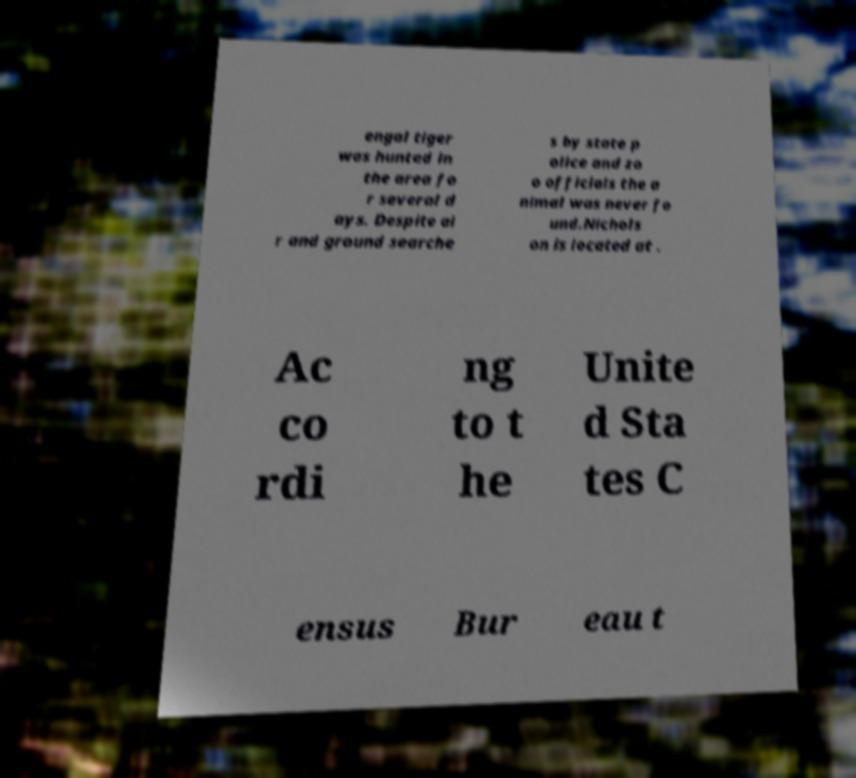What messages or text are displayed in this image? I need them in a readable, typed format. engal tiger was hunted in the area fo r several d ays. Despite ai r and ground searche s by state p olice and zo o officials the a nimal was never fo und.Nichols on is located at . Ac co rdi ng to t he Unite d Sta tes C ensus Bur eau t 